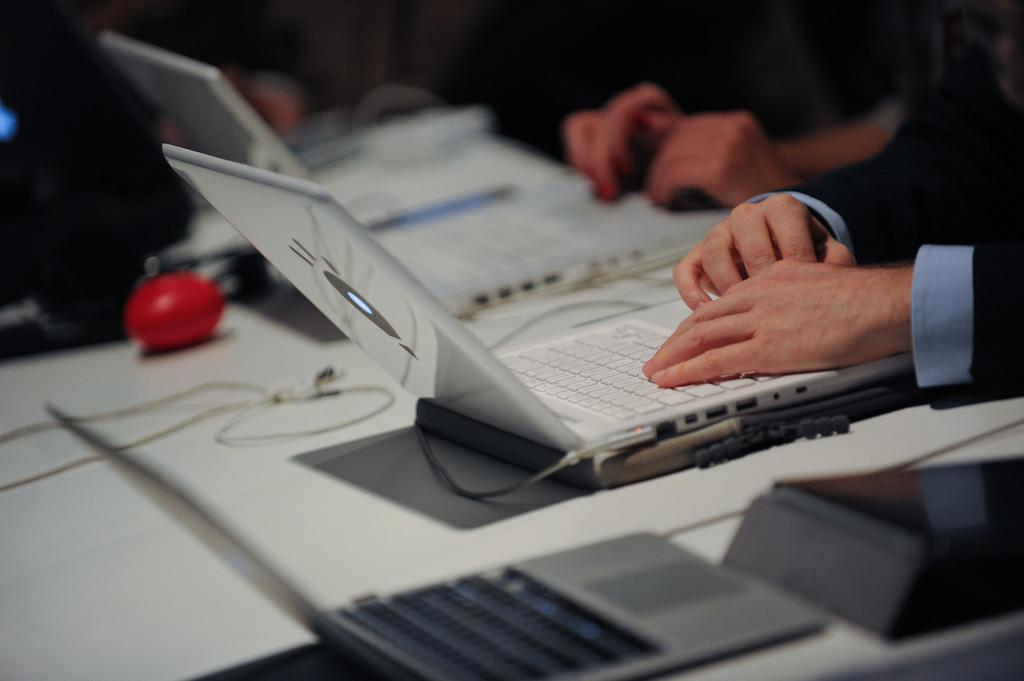What electronic devices are visible in the image? There are laptops in the image. Can you describe the activity of the person in the image? A human is working on a laptop on the right side of the image. How does the person in the image walk while using the laptop? The person in the image is not walking; they are sitting and working on the laptop. 